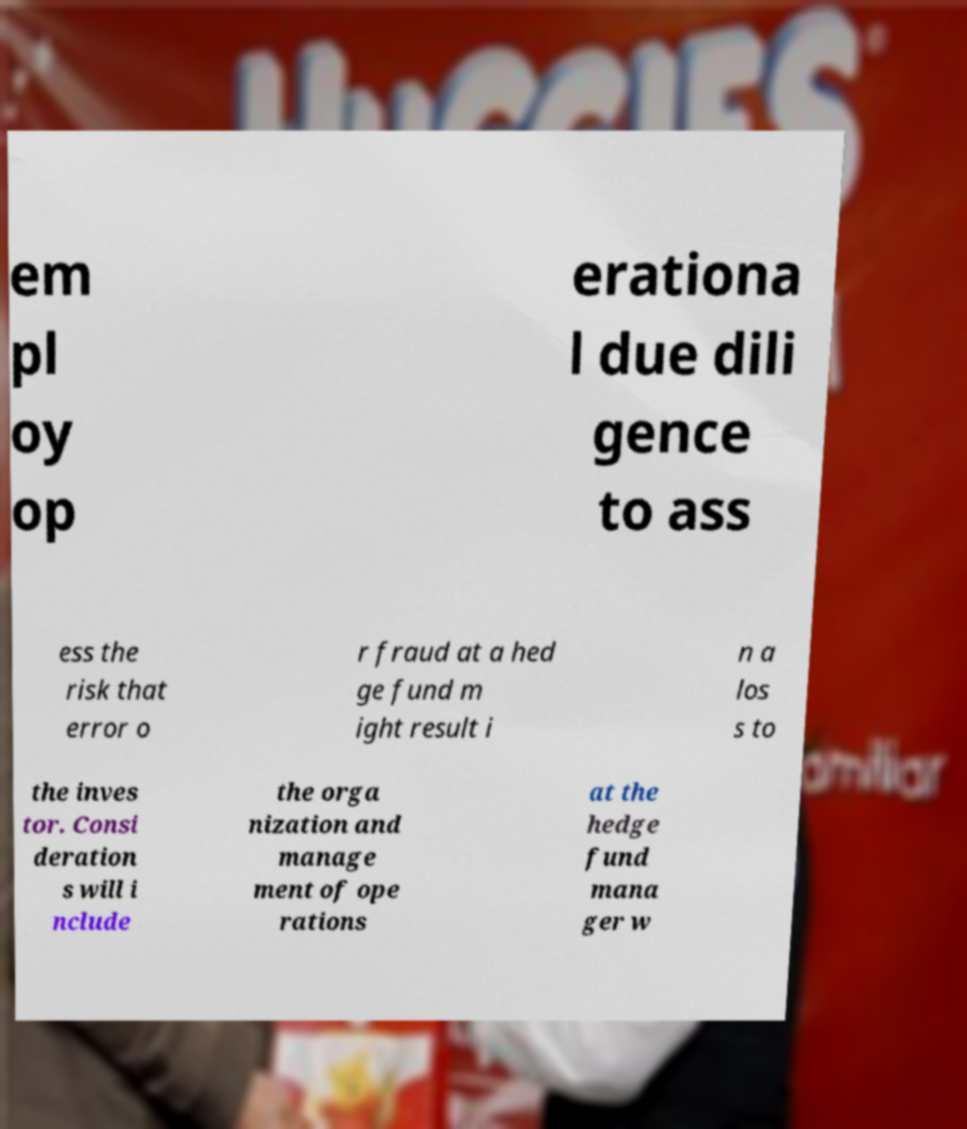What messages or text are displayed in this image? I need them in a readable, typed format. em pl oy op erationa l due dili gence to ass ess the risk that error o r fraud at a hed ge fund m ight result i n a los s to the inves tor. Consi deration s will i nclude the orga nization and manage ment of ope rations at the hedge fund mana ger w 